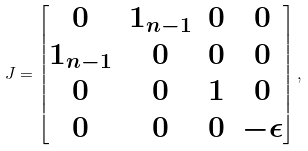Convert formula to latex. <formula><loc_0><loc_0><loc_500><loc_500>J = \begin{bmatrix} 0 & 1 _ { n - 1 } & 0 & 0 \\ 1 _ { n - 1 } & 0 & 0 & 0 \\ 0 & 0 & 1 & 0 \\ 0 & 0 & 0 & - \epsilon \\ \end{bmatrix} ,</formula> 